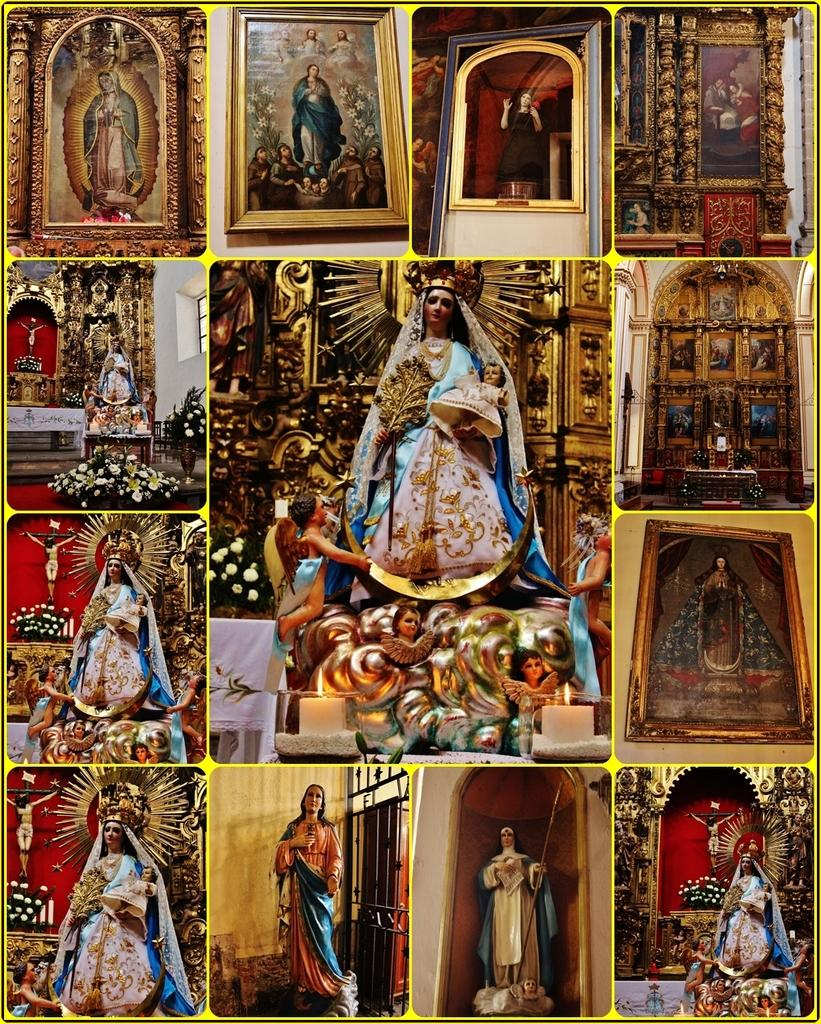What is the main subject of the image? The image contains a collage of pictures. What can be seen around the pictures in the image? There are frames in the image. What do the pictures depict? The pictures depict a person. What type of bait is being used by the person in the image? There is no bait present in the image; the pictures depict a person, but there is no indication of any activity involving bait. 